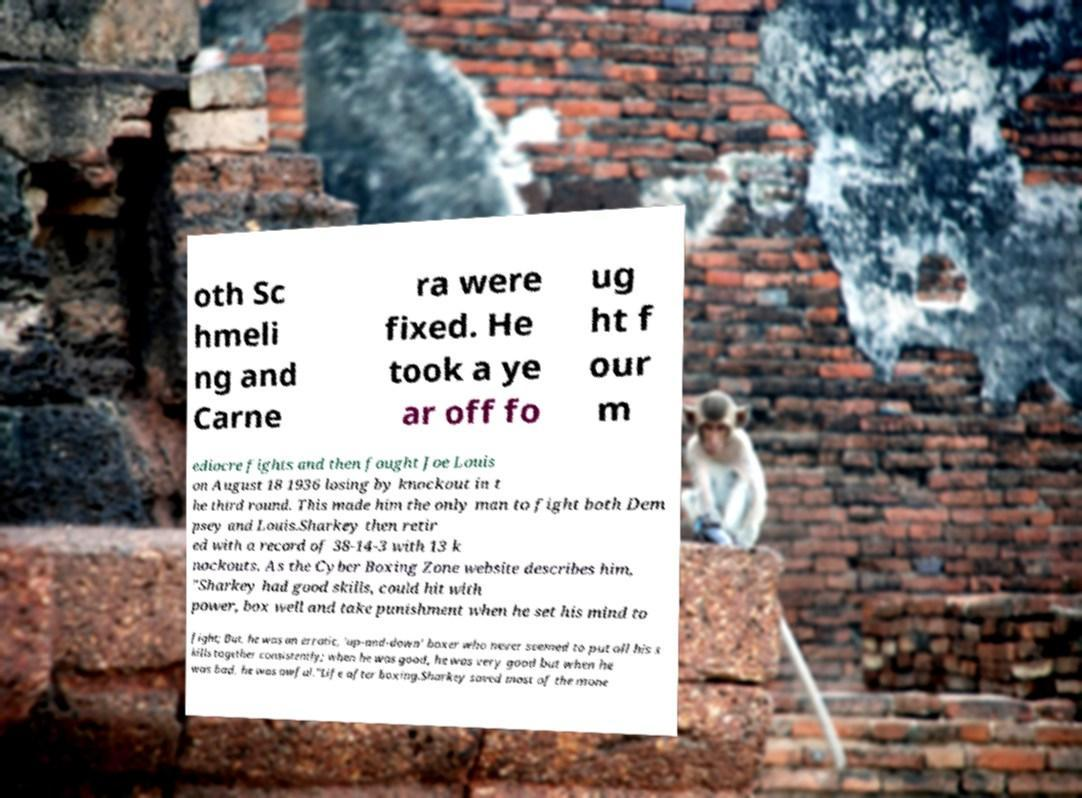I need the written content from this picture converted into text. Can you do that? oth Sc hmeli ng and Carne ra were fixed. He took a ye ar off fo ug ht f our m ediocre fights and then fought Joe Louis on August 18 1936 losing by knockout in t he third round. This made him the only man to fight both Dem psey and Louis.Sharkey then retir ed with a record of 38-14-3 with 13 k nockouts. As the Cyber Boxing Zone website describes him, "Sharkey had good skills, could hit with power, box well and take punishment when he set his mind to fight; But, he was an erratic, 'up-and-down' boxer who never seemed to put all his s kills together consistently; when he was good, he was very good but when he was bad, he was awful."Life after boxing.Sharkey saved most of the mone 